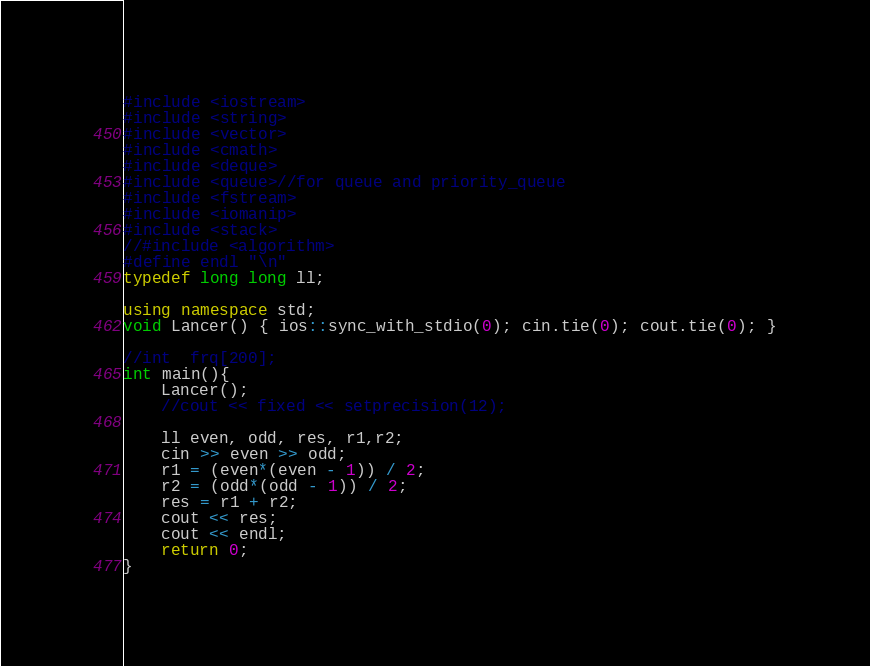Convert code to text. <code><loc_0><loc_0><loc_500><loc_500><_C++_>#include <iostream>
#include <string>
#include <vector>
#include <cmath>
#include <deque>
#include <queue>//for queue and priority_queue
#include <fstream>
#include <iomanip>
#include <stack>
//#include <algorithm>
#define endl "\n"
typedef long long ll;

using namespace std;
void Lancer() { ios::sync_with_stdio(0); cin.tie(0); cout.tie(0); }

//int  frq[200];
int main(){
	Lancer();
	//cout << fixed << setprecision(12);

	ll even, odd, res, r1,r2;
	cin >> even >> odd;
	r1 = (even*(even - 1)) / 2;
	r2 = (odd*(odd - 1)) / 2;
	res = r1 + r2;
	cout << res;
	cout << endl;
	return 0;
}
</code> 